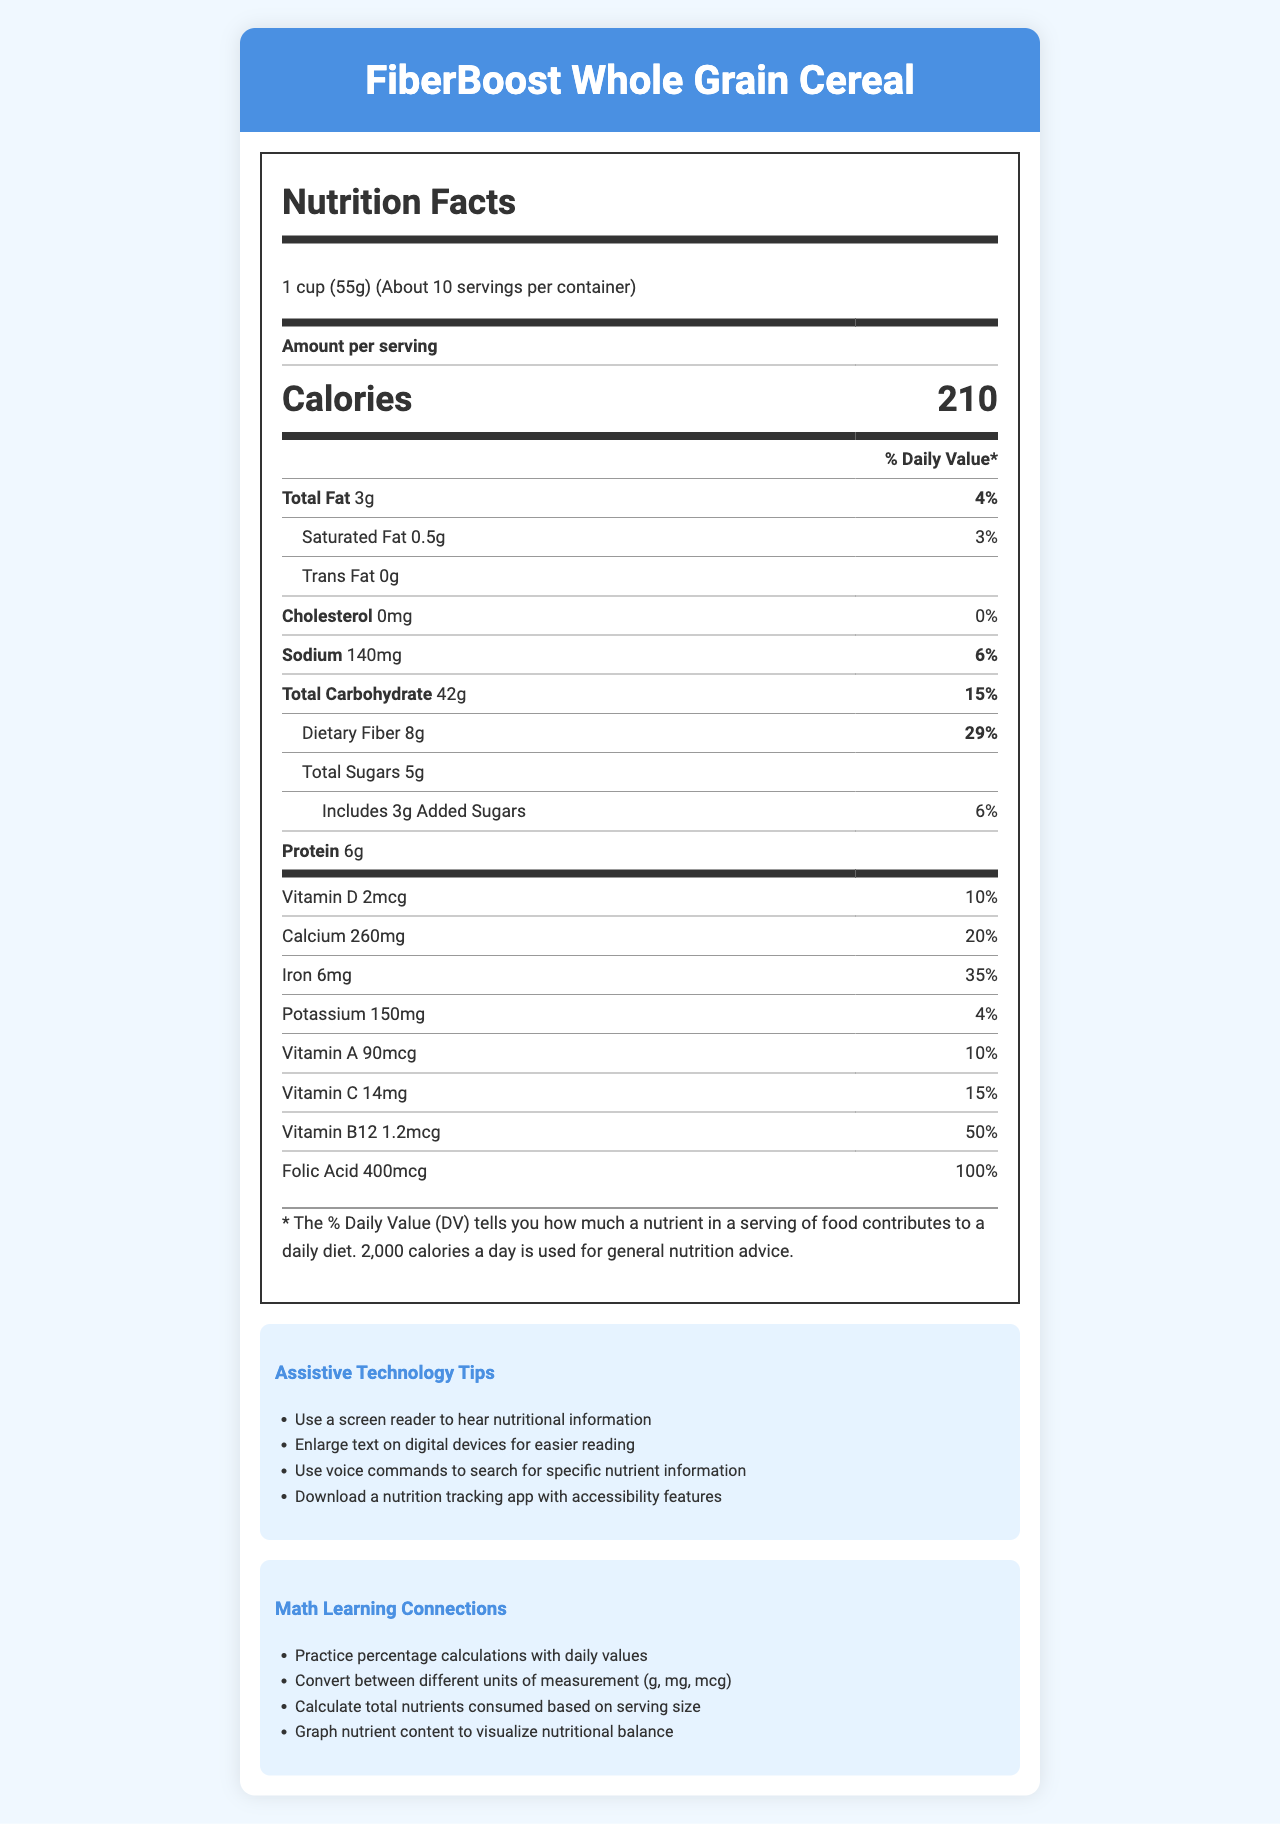What is the serving size for FiberBoost Whole Grain Cereal? The serving size is explicitly mentioned as "1 cup (55g)" in the "Nutrition Facts" section of the document.
Answer: 1 cup (55g) How many calories are there per serving? The document clearly states that each serving contains 210 calories.
Answer: 210 What is the percentage of the daily value for dietary fiber in one serving? The percentage of the daily value for dietary fiber per serving is given as 29%.
Answer: 29% What are the total grams of carbohydrates in one serving? The total carbohydrates per serving are listed as 42g in the "Nutrition Facts" table.
Answer: 42g What is the amount of vitamin C per serving? The amount of vitamin C per serving is shown as 14mg.
Answer: 14mg Which is the highest-percentage daily value vitamin present in the cereal? A. Vitamin D B. Vitamin A C. Vitamin B12 D. Folic Acid The daily value for folic acid is the highest at 100%, compared to the others listed.
Answer: D. Folic Acid How much protein does one serving contain? A. 4g B. 5g C. 6g D. 7g One serving contains 6g of protein according to the information provided.
Answer: C. 6g Is there any cholesterol in FiberBoost Whole Grain Cereal? The document lists cholesterol as "0mg," indicating there is no cholesterol in the cereal.
Answer: No Does the product contain any nuts? The document states that the product may contain traces of nuts, as indicated in the allergen information section.
Answer: May contain traces of nuts Summarize the key nutritional benefits of FiberBoost Whole Grain Cereal. The document highlights these key nutritional benefits in the "special features" section.
Answer: High in fiber, good source of vitamins and minerals, low in saturated fat, cholesterol-free How many servings are there in one container? The document states there are "About 10" servings per container.
Answer: About 10 What ingredient helps provide fiber in this cereal? The ingredient list includes "wheat bran," which is known for its high fiber content.
Answer: Wheat bran What certification does this product have to verify its non-GMO status? The certification section lists "Non-GMO Project Verified" as one of the certifications.
Answer: Non-GMO Project Verified How can someone with a visual impairment access nutritional information more easily? One of the assistive technology tips suggests using a screen reader.
Answer: Use a screen reader to hear nutritional information Calculate the total amount of calcium consumed if you eat two servings. Each serving contains 260mg of calcium, so two servings would provide 520mg.
Answer: 520mg Which tool can be helpful to visualize nutrient balance? The math learning connections section mentions graphing nutrient content as a useful tool.
Answer: Graph nutrient content to visualize nutritional balance What percentage of the daily value of iron does one serving of this cereal provide? The daily value percentage for iron per serving is listed as 35%.
Answer: 35% What is the main source of sweetness in this cereal? The ingredient list includes "cane sugar," indicating it is the main source of sweetness.
Answer: Cane sugar What is the amount of potassium per serving? The document specifies that each serving contains 150mg of potassium.
Answer: 150mg How much trans fat is in one serving of the cereal? The "Nutrition Facts" table shows that the trans fat content is 0g per serving.
Answer: 0g What is the daily value percentage for sodium in one serving? Under the sodium section, the daily value percentage is listed as 6%.
Answer: 6% Which mineral contributes significantly to the daily value with 20%? The document shows that calcium has a daily value percentage of 20%.
Answer: Calcium What feature might make the cereal particularly appealing to health-conscious consumers? One of the special features highlighted is that the cereal is high in fiber, which is appealing to health-conscious consumers.
Answer: High in fiber How many calories are added if you eat an extra serving? Each serving is 210 calories, so an extra serving will add the same amount.
Answer: 210 calories Is the exact date of expiration of the cereal listed in the document? The document does not provide information regarding the expiration date.
Answer: Cannot be determined 